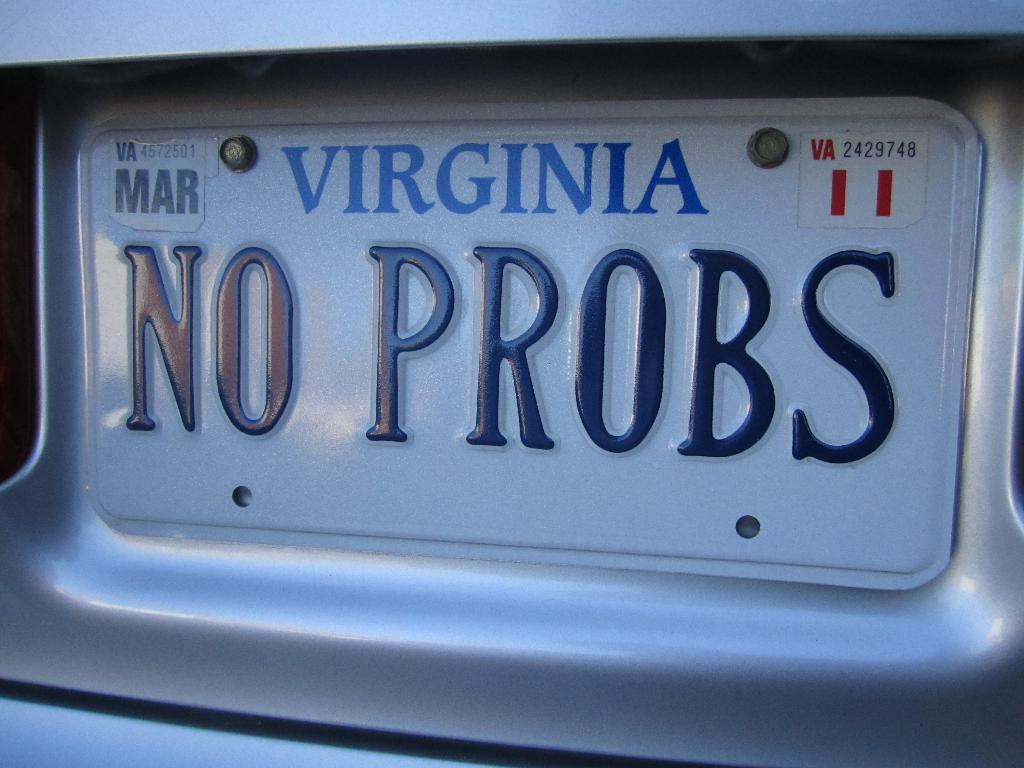Provide a one-sentence caption for the provided image. A No Probs license plate that is from Virginia. 